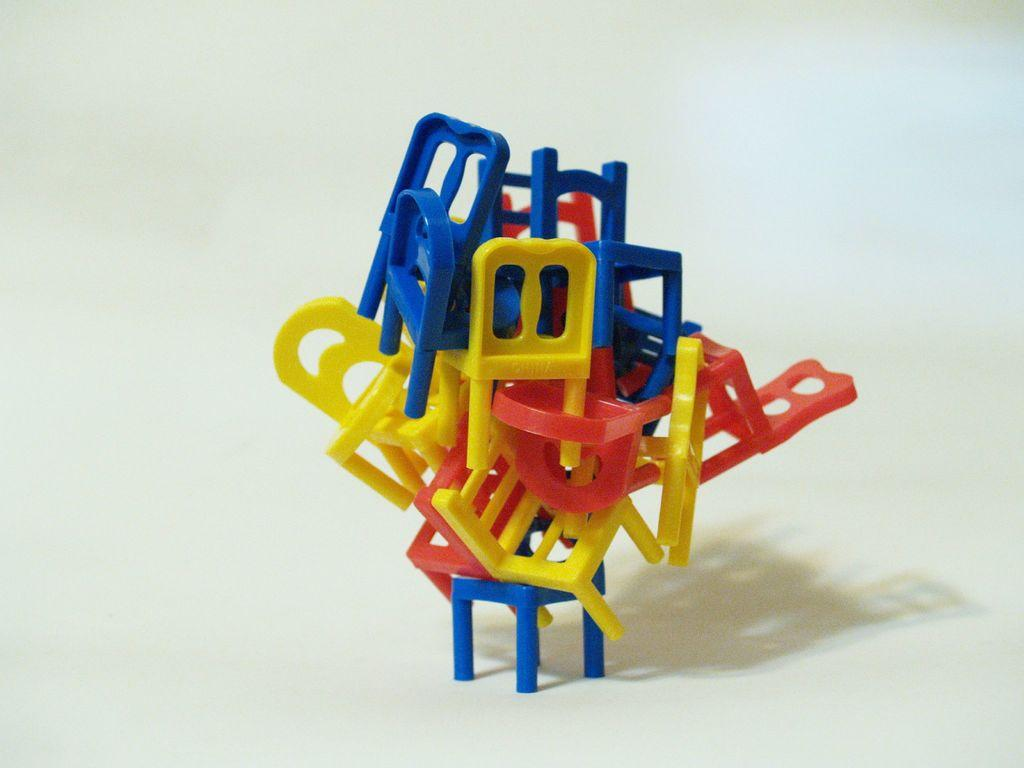What type of furniture is present in the image? There are toy chairs in the image. What can be seen in the background of the image? The background of the image features a plane. What invention is being demonstrated in the image? There is no specific invention being demonstrated in the image; it features toy chairs and a plane in the background. What type of curve can be seen in the image? There is no curve present in the image; it features toy chairs and a plane in the background. 